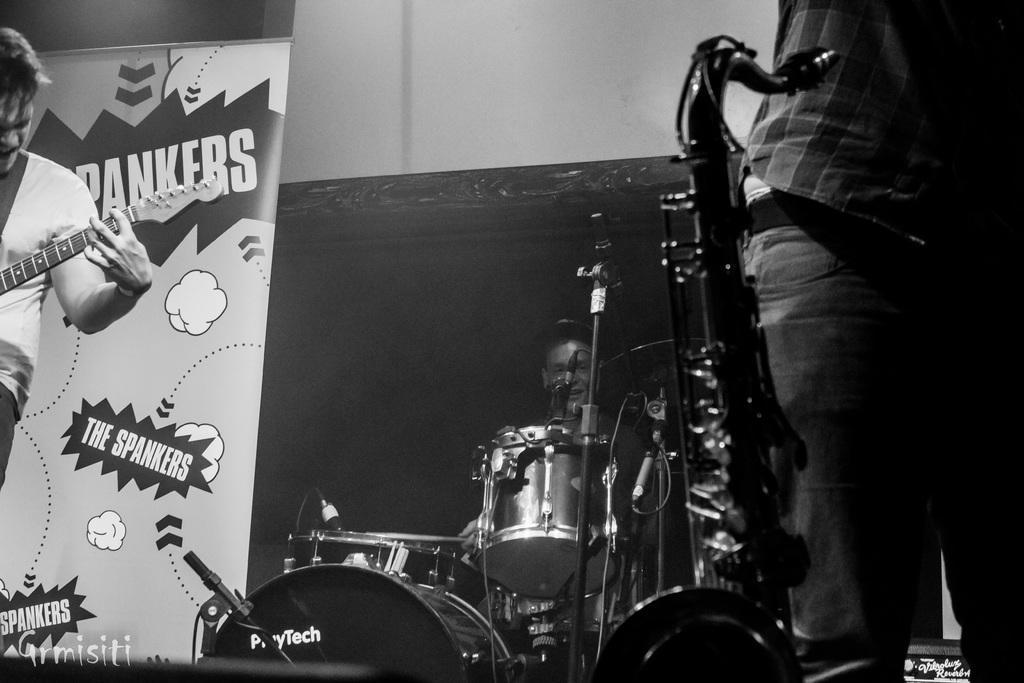Describe this image in one or two sentences. In this picture there are people, among them there is a man playing a guitar and we can see musical instruments and banner. In the background of the image it is dark. 